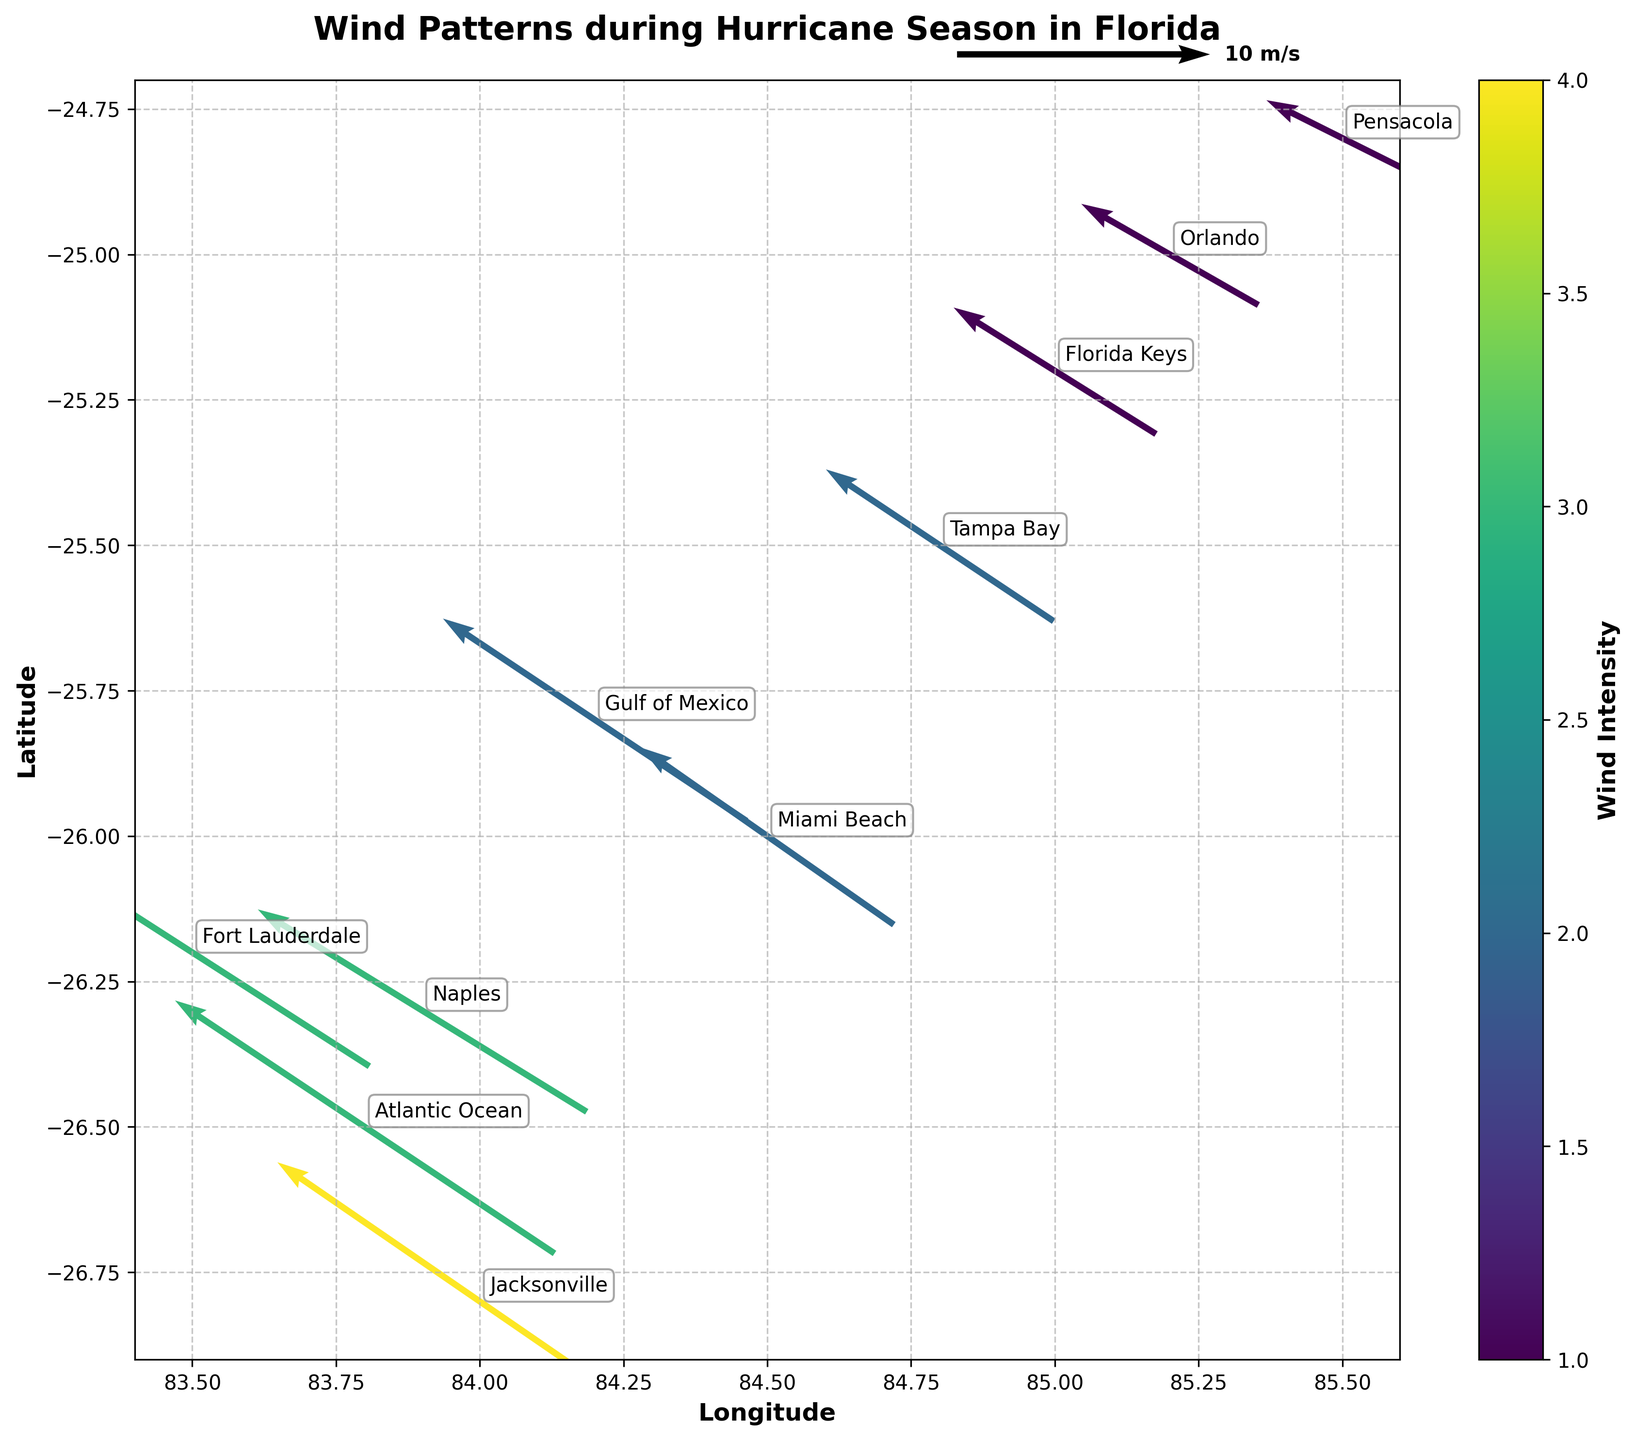What is the title of the quiver plot? The title is mentioned at the top of the plot. It reads "Wind Patterns during Hurricane Season in Florida".
Answer: Wind Patterns during Hurricane Season in Florida How many locations are displayed in the plot? There are points annotated on the plot with different location names: Atlantic Ocean, Gulf of Mexico, Florida Keys, Miami Beach, Fort Lauderdale, Tampa Bay, Orlando, Jacksonville, Naples, Pensacola. Counting these gives us 10.
Answer: 10 Which location has the highest wind intensity? The color mapping indicates the wind intensity. The darkest color corresponds to the highest intensity. Jacksonville, with an intensity value of 4, has the highest wind intensity.
Answer: Jacksonville What are the longitude and latitude coordinates for Miami Beach? Coordinates are indicated by (x, y) on the plot. For Miami Beach, these coordinates are (84.5, -26.0).
Answer: (84.5, -26.0) Compare the wind direction in Atlantic Ocean vs. Gulf of Mexico. Which one has a stronger wind vector magnitude? The wind vector magnitude can be estimated from the length of the arrows. The Atlantic Ocean's magnitude is calculated as sqrt((-15)^2 + 10^2) = 18 approximately, while Gulf of Mexico's magnitude is sqrt((-12)^2 + 8^2) = 14 approximately. Hence, Atlantic Ocean has a stronger wind vector magnitude.
Answer: Atlantic Ocean How does the wind direction in Pensacola compare to the rest of Florida locations? Pensacola's wind direction vector is (-6, 3). Compared to other locations, it has a relatively smaller magnitude and points in a more northeast direction compared to most other vectors.
Answer: Northeast, weaker compared to most points Which location has the wind blowing most directly south? The wind direction vector indicates the direction. The components of the vector should be mostly negative y and minimal x. For Naples (-13, 8), the x-component is minimal negative compared to other points with negative y-components.
Answer: Naples How is the wind intensity distributed among multiple locations? By observing the color gradient and the intensity values annotated, it shows varied intensity levels with Jacksonville at 4, Atlantic Ocean at 3, Fort Lauderdale at 3, Naples at 3, Gulf of Mexico, Miami Beach, Tampa Bay at 2, Florida Keys, Orlando, Pensacola at 1.
Answer: Varied, mostly between 1 to 4 What is the trend in wind direction from Jacksonville to Miami Beach? By visually tracing the vectors, the winds start strong and northwesterly from Jacksonville and weaken towards some southeast direction when reaching Miami Beach.
Answer: Northwesterly to southeastward, weakening Why might locations with low altitudes experience higher wind intensities? Lower altitudes over water bodies minimizing surface friction might explain the higher wind intensities, as seen over Atlantic Ocean and Jacksonville which are coastal/in proximity to the sea.
Answer: Lower surface friction near water bodies 